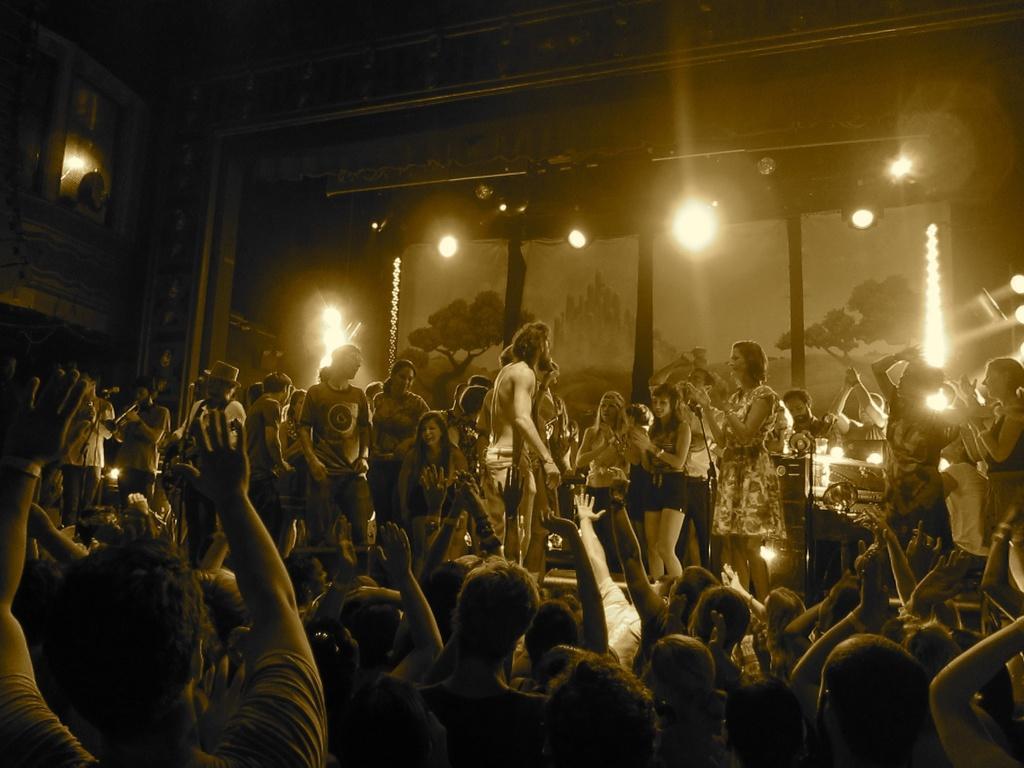Can you describe this image briefly? This image consists of a huge crowd. It looks like it is clicked in a pub. In the background, we can see many light. At the top, there is a roof. On the left, there is a window. In the middle, there is a man talking in a mic. 